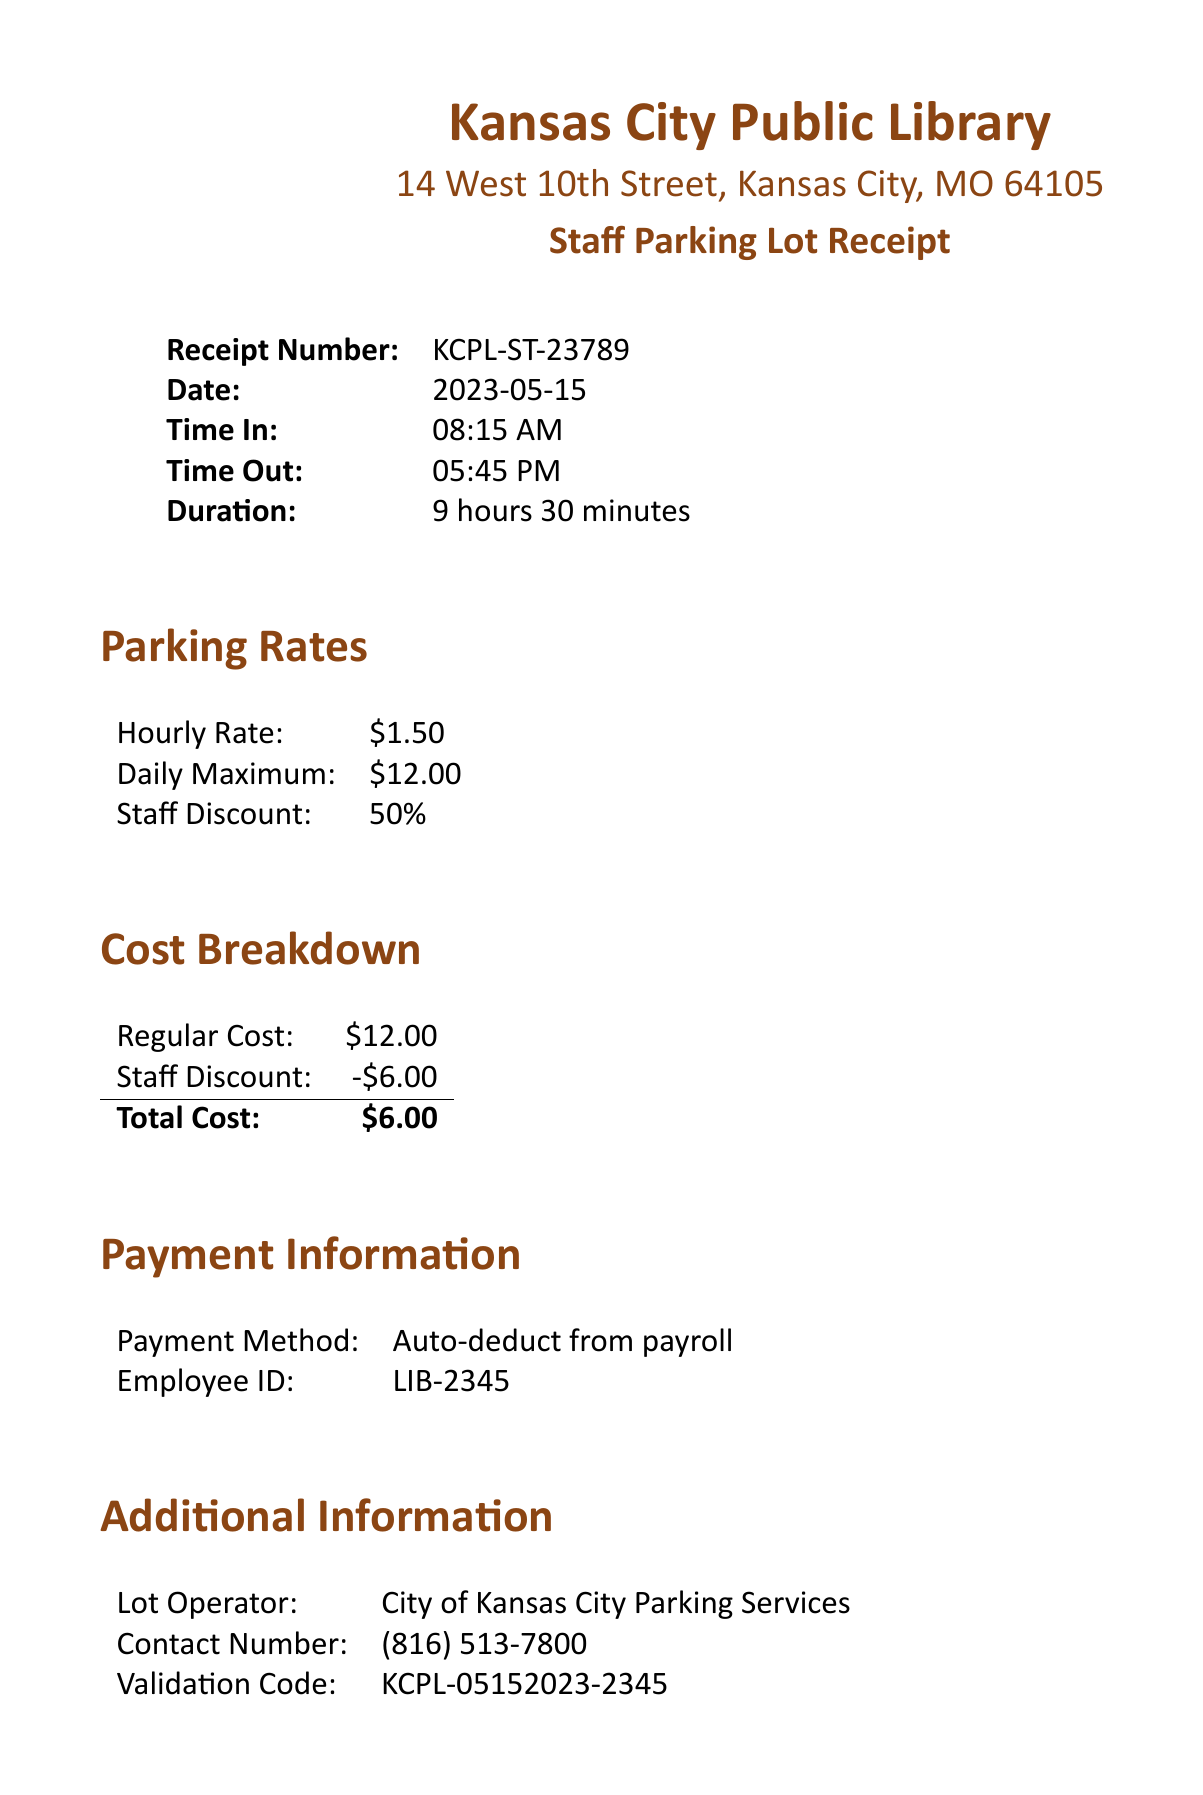What is the library's address? The address is provided in the receipt header, which states "14 West 10th Street, Kansas City, MO 64105."
Answer: 14 West 10th Street, Kansas City, MO 64105 What is the receipt number? The receipt number is a specific detail provided in the transaction details section of the document, listed as "KCPL-ST-23789."
Answer: KCPL-ST-23789 What was the duration of parking? The duration is stated in the transaction details as "9 hours 30 minutes."
Answer: 9 hours 30 minutes What is the staff discount percentage? The staff discount is mentioned in the parking rates section as "50%."
Answer: 50% What is the total cost after discount? The total cost is calculated in the cost breakdown section as "$6.00" after applying the staff discount.
Answer: $6.00 What method was used for payment? The method of payment is detailed in the payment information section as "Auto-deduct from payroll."
Answer: Auto-deduct from payroll Who operates the parking lot? The operator of the parking lot is specified in the additional information section, listed as "City of Kansas City Parking Services."
Answer: City of Kansas City Parking Services What should be displayed while parked? Important notes mention that the receipt should be displayed on the dashboard when parked.
Answer: This receipt What to do if you lose the ticket? The important notes section states that lost tickets will be charged the daily maximum rate.
Answer: Charged the daily maximum rate 